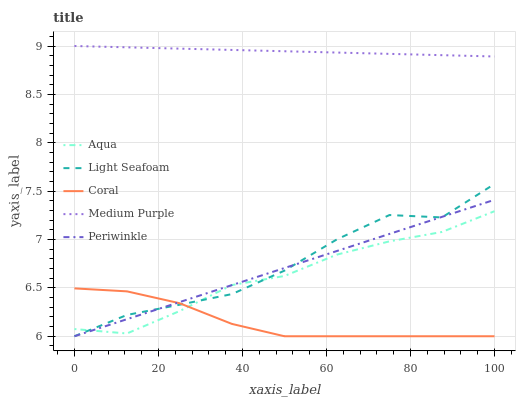Does Coral have the minimum area under the curve?
Answer yes or no. Yes. Does Medium Purple have the maximum area under the curve?
Answer yes or no. Yes. Does Periwinkle have the minimum area under the curve?
Answer yes or no. No. Does Periwinkle have the maximum area under the curve?
Answer yes or no. No. Is Periwinkle the smoothest?
Answer yes or no. Yes. Is Light Seafoam the roughest?
Answer yes or no. Yes. Is Coral the smoothest?
Answer yes or no. No. Is Coral the roughest?
Answer yes or no. No. Does Periwinkle have the lowest value?
Answer yes or no. Yes. Does Aqua have the lowest value?
Answer yes or no. No. Does Medium Purple have the highest value?
Answer yes or no. Yes. Does Periwinkle have the highest value?
Answer yes or no. No. Is Light Seafoam less than Medium Purple?
Answer yes or no. Yes. Is Medium Purple greater than Light Seafoam?
Answer yes or no. Yes. Does Light Seafoam intersect Coral?
Answer yes or no. Yes. Is Light Seafoam less than Coral?
Answer yes or no. No. Is Light Seafoam greater than Coral?
Answer yes or no. No. Does Light Seafoam intersect Medium Purple?
Answer yes or no. No. 